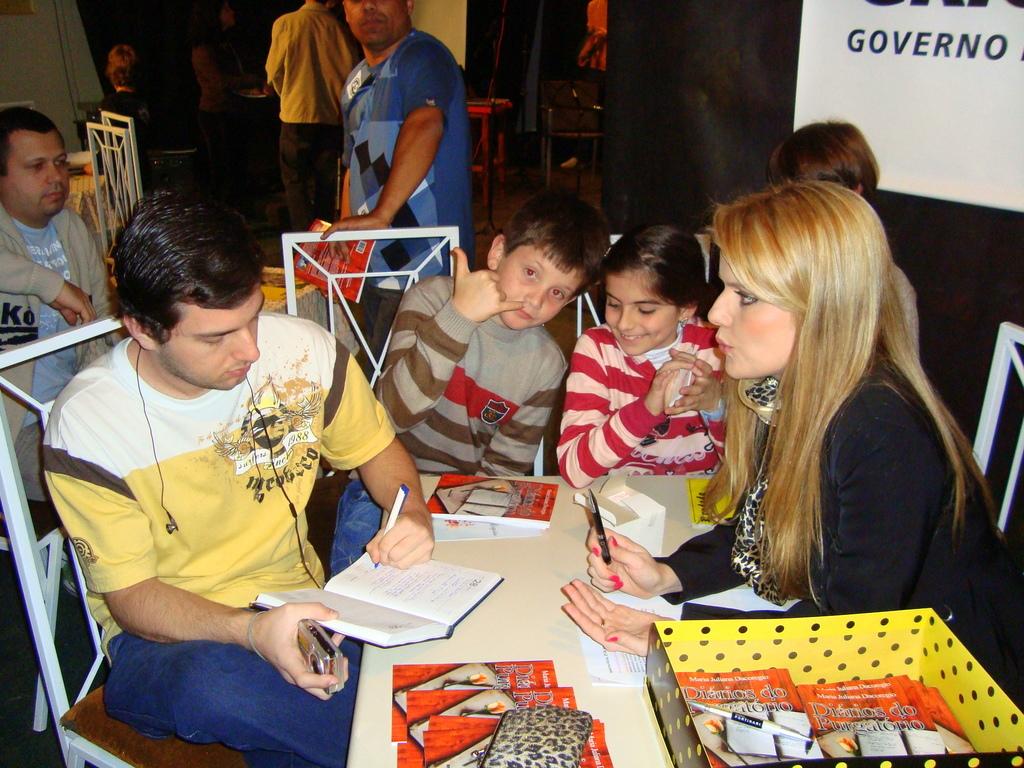Is that boy displaying the calling sign?
Your answer should be compact. Answering does not require reading text in the image. What word is visible on the white sign in the top corner?
Make the answer very short. Governo. 